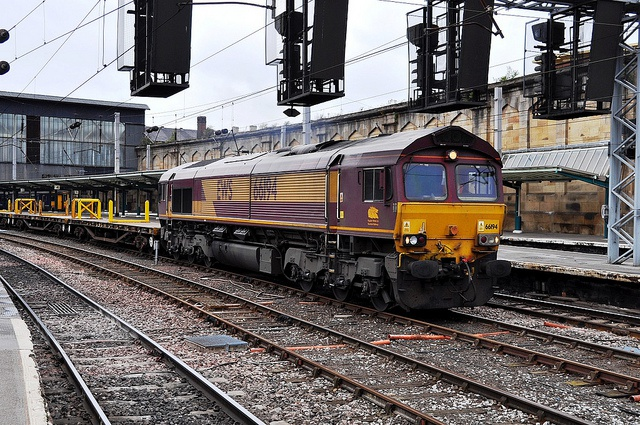Describe the objects in this image and their specific colors. I can see a train in lavender, black, gray, lightgray, and olive tones in this image. 